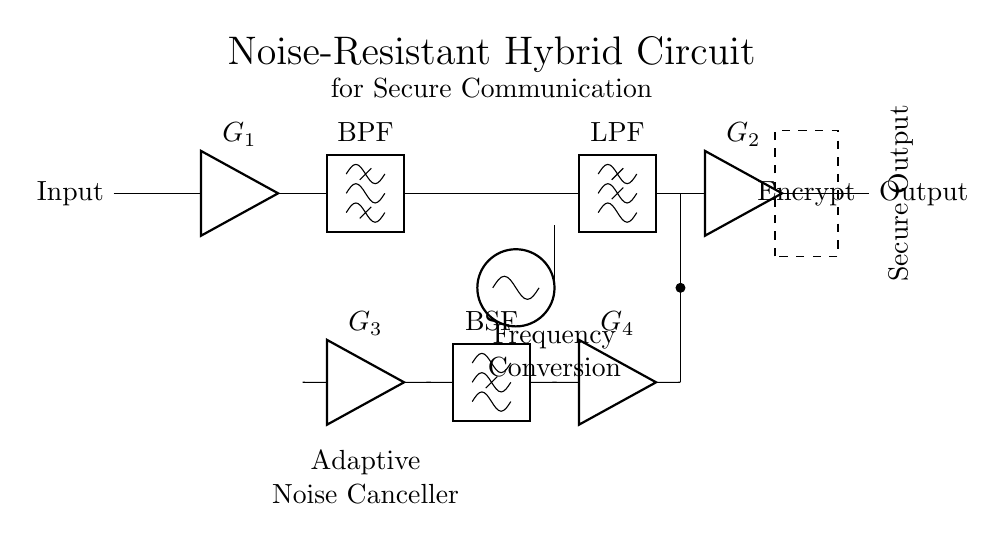What is the main function of the BPF? The bandpass filter (BPF) allows signals within a certain frequency range to pass while attenuating signals outside that range, ensuring only the desired frequencies feed into subsequent components.
Answer: Signal filtering What type of amplifier is labeled G2? G2 represents a standard amplifier that boosts the signal after processing. It's identified by the label directly next to it in the circuit diagram.
Answer: Amplifier How many amplifiers are present in the circuit? There are four amplifiers: G1, G2, G3, and G4, which can be counted directly in the circuit diagram.
Answer: Four What does the dashed rectangle represent? The dashed rectangle indicates a block for encryption, a critical part for securing the signal after its processing through the circuit.
Answer: Encryption block Which component is responsible for noise cancellation? The noise cancellation is handled by the adaptive noise canceller circuit involving amplifiers G3 and G4 alongside a bandstop filter (BSF), effectively removing unwanted noise signals.
Answer: Adaptive Noise Canceller What is the purpose of the lowpass filter (LPF)? The lowpass filter (LPF) allows low-frequency signals to pass through while attenuating high-frequency noise, contributing to cleaner output signals.
Answer: Noise reduction What is the role of the local oscillator (LO)? The local oscillator is used for frequency conversion, generating a signal that enables the mixing process necessary for modulating the input signal to a desired frequency, which helps in the secure communication process.
Answer: Frequency conversion 